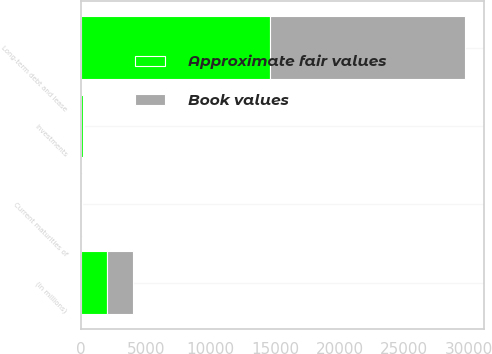Convert chart. <chart><loc_0><loc_0><loc_500><loc_500><stacked_bar_chart><ecel><fcel>(in millions)<fcel>Investments<fcel>Current maturities of<fcel>Long-term debt and lease<nl><fcel>Approximate fair values<fcel>2012<fcel>107<fcel>22<fcel>14630<nl><fcel>Book values<fcel>2012<fcel>104<fcel>22<fcel>15066<nl></chart> 